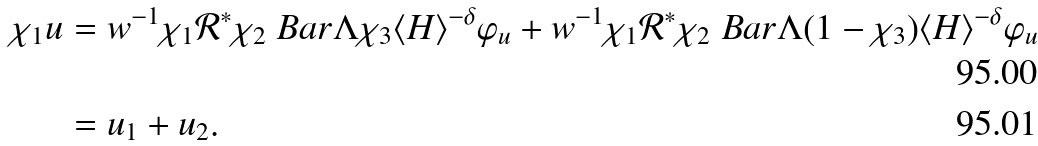<formula> <loc_0><loc_0><loc_500><loc_500>\chi _ { 1 } u & = w ^ { - 1 } \chi _ { 1 } \mathcal { R } ^ { * } \chi _ { 2 } \ B a r \Lambda \chi _ { 3 } \langle H \rangle ^ { - \delta } \varphi _ { u } + w ^ { - 1 } \chi _ { 1 } \mathcal { R } ^ { * } \chi _ { 2 } \ B a r \Lambda ( 1 - \chi _ { 3 } ) \langle H \rangle ^ { - \delta } \varphi _ { u } \\ & = u _ { 1 } + u _ { 2 } .</formula> 